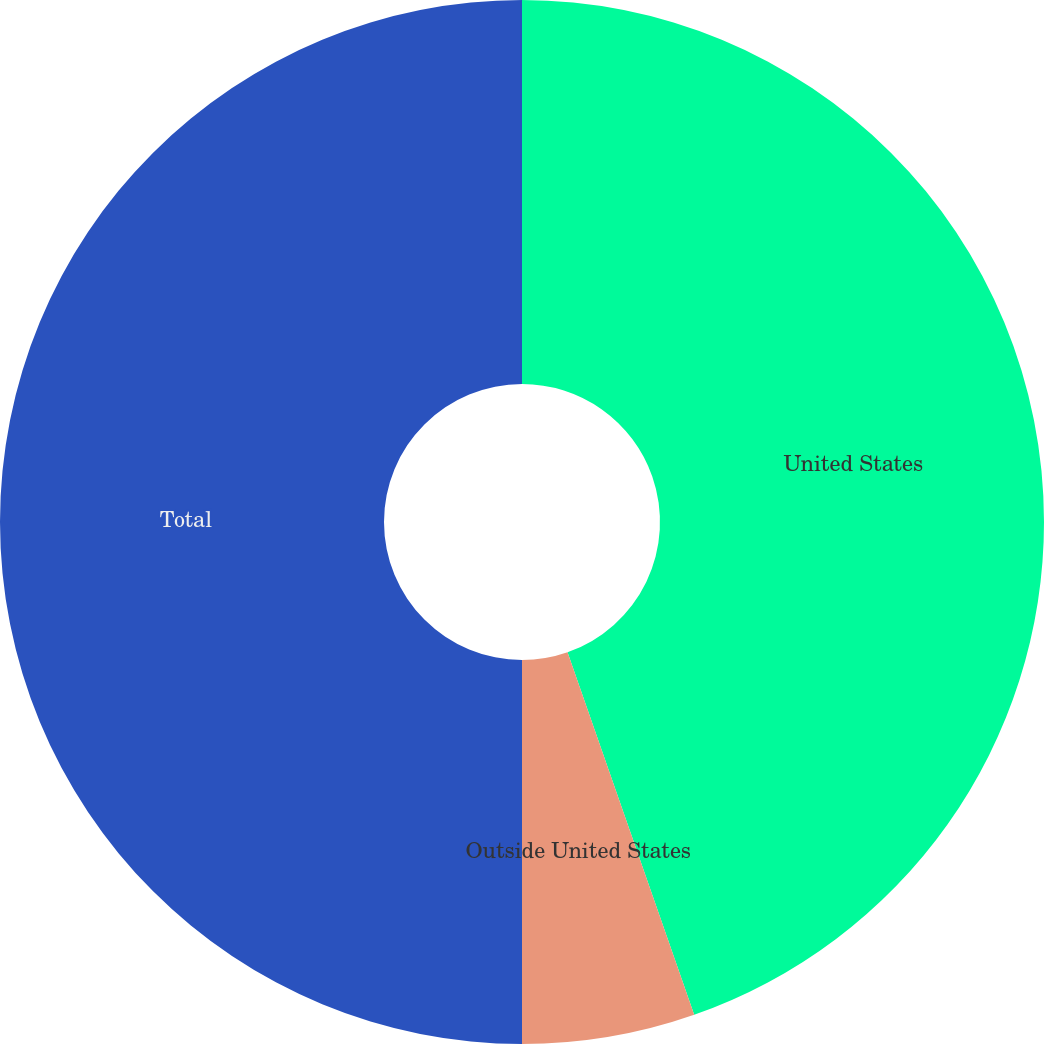Convert chart. <chart><loc_0><loc_0><loc_500><loc_500><pie_chart><fcel>United States<fcel>Outside United States<fcel>Total<nl><fcel>44.65%<fcel>5.35%<fcel>50.0%<nl></chart> 